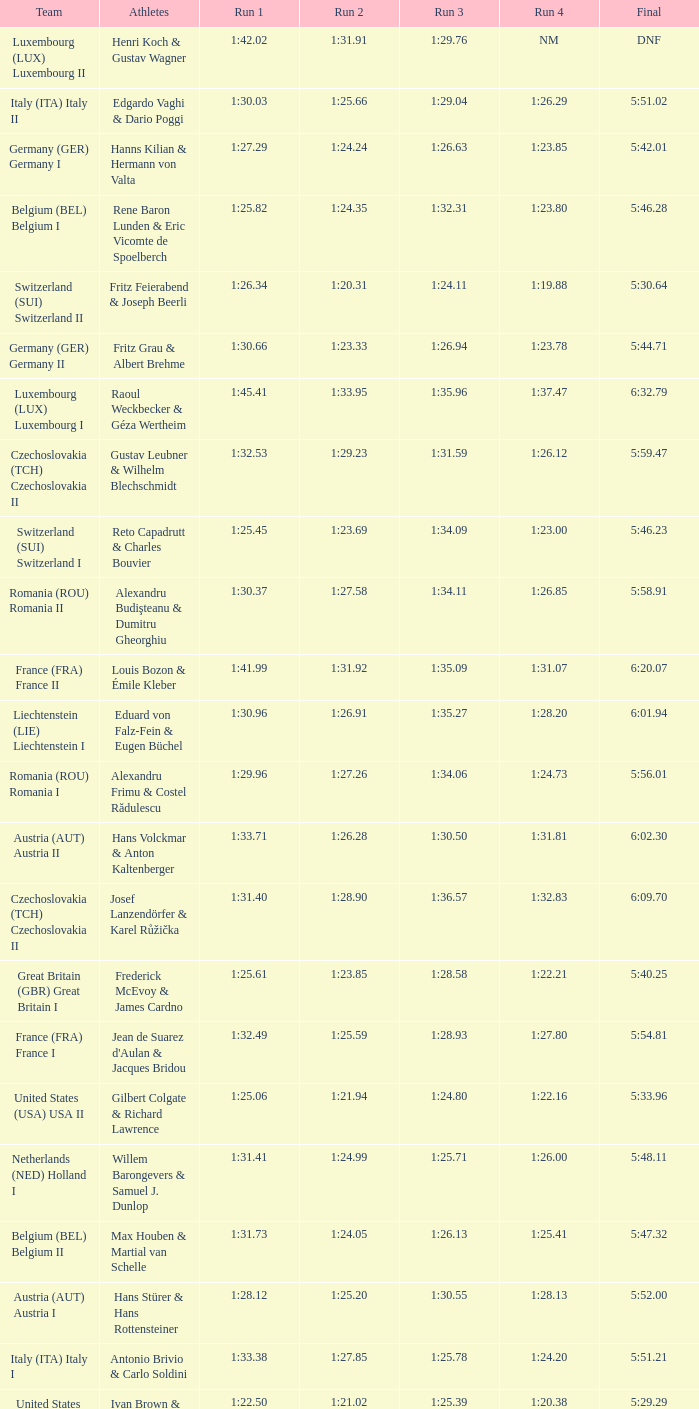Which Run 4 has a Run 1 of 1:25.82? 1:23.80. 